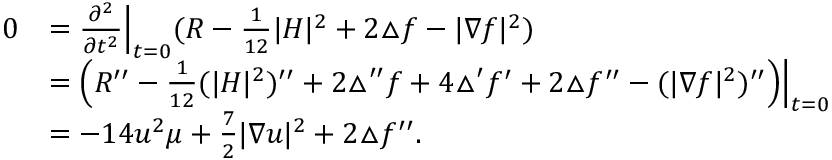<formula> <loc_0><loc_0><loc_500><loc_500>\begin{array} { r l } { 0 } & { = \frac { \partial ^ { 2 } } { \partial t ^ { 2 } } \left | _ { t = 0 } ( R - \frac { 1 } { 1 2 } | H | ^ { 2 } + 2 \triangle f - | \nabla f | ^ { 2 } ) } \\ & { = \left ( R ^ { \prime \prime } - \frac { 1 } { 1 2 } ( | H | ^ { 2 } ) ^ { \prime \prime } + 2 \triangle ^ { \prime \prime } f + 4 \triangle ^ { \prime } f ^ { \prime } + 2 \triangle f ^ { \prime \prime } - ( | \nabla f | ^ { 2 } ) ^ { \prime \prime } \right ) \right | _ { t = 0 } } \\ & { = - 1 4 u ^ { 2 } \mu + \frac { 7 } { 2 } | \nabla u | ^ { 2 } + 2 \triangle f ^ { \prime \prime } . } \end{array}</formula> 